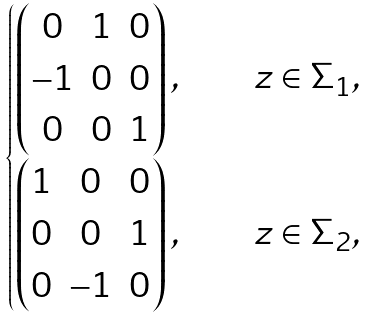<formula> <loc_0><loc_0><loc_500><loc_500>\begin{cases} \begin{pmatrix} 0 & 1 & 0 \\ - 1 & 0 & 0 \\ 0 & 0 & 1 \end{pmatrix} , & \quad z \in \Sigma _ { 1 } , \\ \begin{pmatrix} 1 & 0 & 0 \\ 0 & 0 & 1 \\ 0 & - 1 & 0 \end{pmatrix} , & \quad z \in \Sigma _ { 2 } , \end{cases}</formula> 